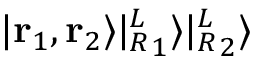<formula> <loc_0><loc_0><loc_500><loc_500>| r _ { 1 } , r _ { 2 } \rangle | { ^ { L } _ { R } } _ { 1 } \rangle | { ^ { L } _ { R } } _ { 2 } \rangle</formula> 